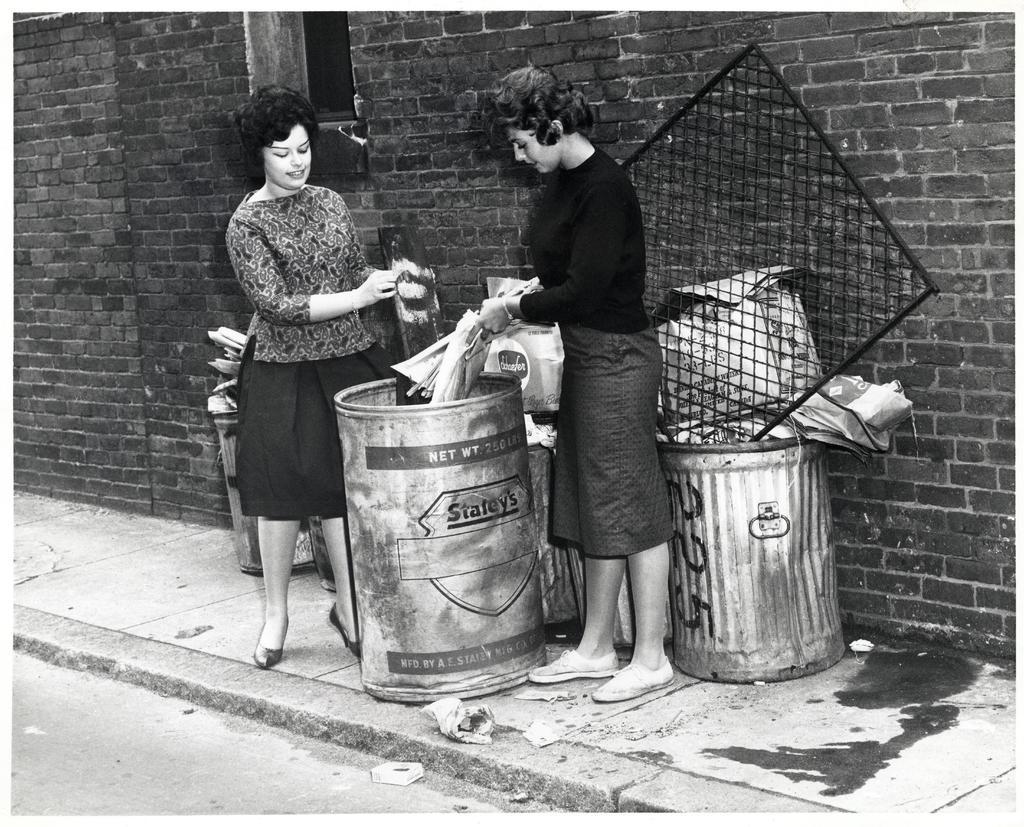What number is on the garbage can?
Your answer should be compact. 225. What company made the garbage can?
Your answer should be compact. Staley's. 